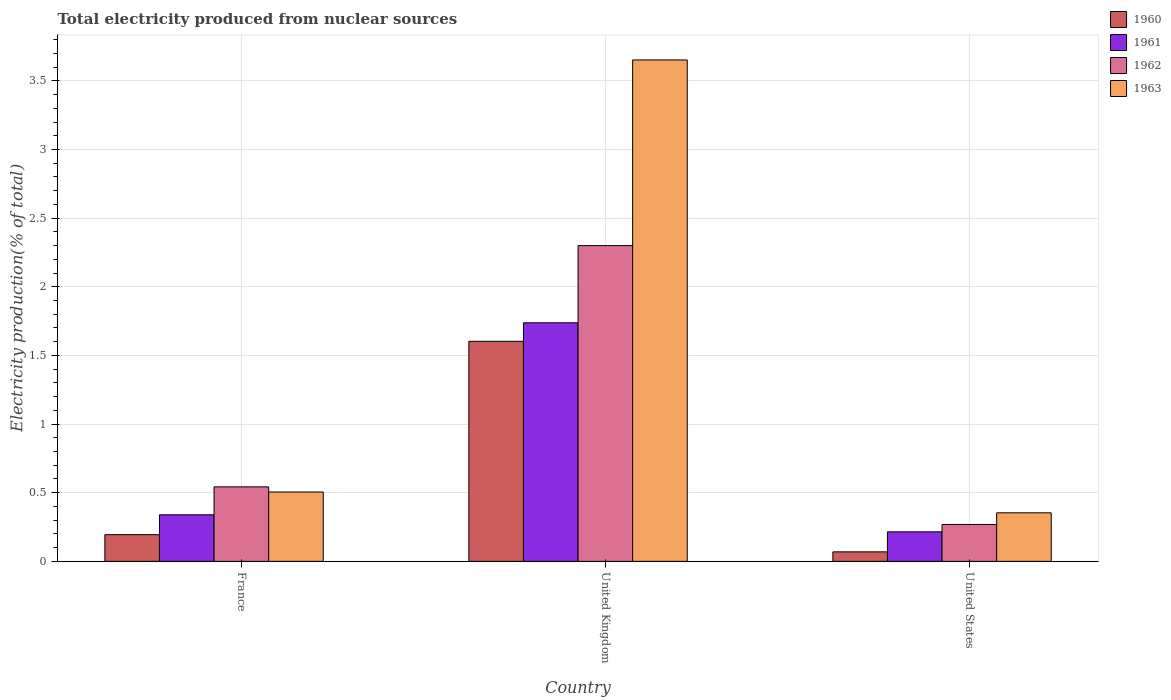How many different coloured bars are there?
Your answer should be very brief. 4. How many groups of bars are there?
Give a very brief answer. 3. Are the number of bars on each tick of the X-axis equal?
Keep it short and to the point. Yes. How many bars are there on the 3rd tick from the left?
Offer a very short reply. 4. What is the label of the 1st group of bars from the left?
Make the answer very short. France. In how many cases, is the number of bars for a given country not equal to the number of legend labels?
Your answer should be very brief. 0. What is the total electricity produced in 1961 in United Kingdom?
Give a very brief answer. 1.74. Across all countries, what is the maximum total electricity produced in 1962?
Your response must be concise. 2.3. Across all countries, what is the minimum total electricity produced in 1960?
Your answer should be compact. 0.07. What is the total total electricity produced in 1960 in the graph?
Your response must be concise. 1.87. What is the difference between the total electricity produced in 1960 in France and that in United Kingdom?
Make the answer very short. -1.41. What is the difference between the total electricity produced in 1962 in United Kingdom and the total electricity produced in 1960 in France?
Your answer should be very brief. 2.11. What is the average total electricity produced in 1963 per country?
Your response must be concise. 1.5. What is the difference between the total electricity produced of/in 1961 and total electricity produced of/in 1960 in France?
Your response must be concise. 0.14. In how many countries, is the total electricity produced in 1960 greater than 1.7 %?
Keep it short and to the point. 0. What is the ratio of the total electricity produced in 1962 in United Kingdom to that in United States?
Ensure brevity in your answer.  8.56. Is the total electricity produced in 1961 in France less than that in United States?
Your answer should be compact. No. Is the difference between the total electricity produced in 1961 in France and United States greater than the difference between the total electricity produced in 1960 in France and United States?
Make the answer very short. No. What is the difference between the highest and the second highest total electricity produced in 1963?
Your answer should be compact. -3.15. What is the difference between the highest and the lowest total electricity produced in 1963?
Give a very brief answer. 3.3. In how many countries, is the total electricity produced in 1960 greater than the average total electricity produced in 1960 taken over all countries?
Your answer should be compact. 1. Is the sum of the total electricity produced in 1963 in United Kingdom and United States greater than the maximum total electricity produced in 1961 across all countries?
Ensure brevity in your answer.  Yes. Is it the case that in every country, the sum of the total electricity produced in 1961 and total electricity produced in 1963 is greater than the sum of total electricity produced in 1962 and total electricity produced in 1960?
Provide a short and direct response. Yes. Is it the case that in every country, the sum of the total electricity produced in 1961 and total electricity produced in 1963 is greater than the total electricity produced in 1960?
Provide a succinct answer. Yes. How many bars are there?
Offer a terse response. 12. Are all the bars in the graph horizontal?
Make the answer very short. No. How many countries are there in the graph?
Give a very brief answer. 3. Does the graph contain any zero values?
Offer a very short reply. No. Where does the legend appear in the graph?
Your answer should be very brief. Top right. What is the title of the graph?
Provide a short and direct response. Total electricity produced from nuclear sources. Does "2010" appear as one of the legend labels in the graph?
Your answer should be compact. No. What is the label or title of the Y-axis?
Make the answer very short. Electricity production(% of total). What is the Electricity production(% of total) of 1960 in France?
Make the answer very short. 0.19. What is the Electricity production(% of total) of 1961 in France?
Your answer should be compact. 0.34. What is the Electricity production(% of total) in 1962 in France?
Your answer should be very brief. 0.54. What is the Electricity production(% of total) of 1963 in France?
Provide a succinct answer. 0.51. What is the Electricity production(% of total) in 1960 in United Kingdom?
Keep it short and to the point. 1.6. What is the Electricity production(% of total) of 1961 in United Kingdom?
Your response must be concise. 1.74. What is the Electricity production(% of total) in 1962 in United Kingdom?
Your answer should be compact. 2.3. What is the Electricity production(% of total) in 1963 in United Kingdom?
Make the answer very short. 3.65. What is the Electricity production(% of total) of 1960 in United States?
Keep it short and to the point. 0.07. What is the Electricity production(% of total) of 1961 in United States?
Make the answer very short. 0.22. What is the Electricity production(% of total) in 1962 in United States?
Provide a short and direct response. 0.27. What is the Electricity production(% of total) in 1963 in United States?
Offer a very short reply. 0.35. Across all countries, what is the maximum Electricity production(% of total) in 1960?
Make the answer very short. 1.6. Across all countries, what is the maximum Electricity production(% of total) of 1961?
Keep it short and to the point. 1.74. Across all countries, what is the maximum Electricity production(% of total) in 1962?
Offer a very short reply. 2.3. Across all countries, what is the maximum Electricity production(% of total) in 1963?
Your answer should be very brief. 3.65. Across all countries, what is the minimum Electricity production(% of total) in 1960?
Your response must be concise. 0.07. Across all countries, what is the minimum Electricity production(% of total) of 1961?
Your response must be concise. 0.22. Across all countries, what is the minimum Electricity production(% of total) in 1962?
Your answer should be compact. 0.27. Across all countries, what is the minimum Electricity production(% of total) of 1963?
Keep it short and to the point. 0.35. What is the total Electricity production(% of total) in 1960 in the graph?
Offer a terse response. 1.87. What is the total Electricity production(% of total) of 1961 in the graph?
Provide a short and direct response. 2.29. What is the total Electricity production(% of total) of 1962 in the graph?
Ensure brevity in your answer.  3.11. What is the total Electricity production(% of total) in 1963 in the graph?
Ensure brevity in your answer.  4.51. What is the difference between the Electricity production(% of total) of 1960 in France and that in United Kingdom?
Make the answer very short. -1.41. What is the difference between the Electricity production(% of total) in 1961 in France and that in United Kingdom?
Make the answer very short. -1.4. What is the difference between the Electricity production(% of total) in 1962 in France and that in United Kingdom?
Offer a terse response. -1.76. What is the difference between the Electricity production(% of total) in 1963 in France and that in United Kingdom?
Offer a terse response. -3.15. What is the difference between the Electricity production(% of total) of 1960 in France and that in United States?
Ensure brevity in your answer.  0.13. What is the difference between the Electricity production(% of total) in 1961 in France and that in United States?
Make the answer very short. 0.12. What is the difference between the Electricity production(% of total) in 1962 in France and that in United States?
Provide a succinct answer. 0.27. What is the difference between the Electricity production(% of total) of 1963 in France and that in United States?
Offer a terse response. 0.15. What is the difference between the Electricity production(% of total) in 1960 in United Kingdom and that in United States?
Your response must be concise. 1.53. What is the difference between the Electricity production(% of total) in 1961 in United Kingdom and that in United States?
Give a very brief answer. 1.52. What is the difference between the Electricity production(% of total) in 1962 in United Kingdom and that in United States?
Provide a succinct answer. 2.03. What is the difference between the Electricity production(% of total) in 1963 in United Kingdom and that in United States?
Give a very brief answer. 3.3. What is the difference between the Electricity production(% of total) in 1960 in France and the Electricity production(% of total) in 1961 in United Kingdom?
Keep it short and to the point. -1.54. What is the difference between the Electricity production(% of total) in 1960 in France and the Electricity production(% of total) in 1962 in United Kingdom?
Keep it short and to the point. -2.11. What is the difference between the Electricity production(% of total) of 1960 in France and the Electricity production(% of total) of 1963 in United Kingdom?
Provide a succinct answer. -3.46. What is the difference between the Electricity production(% of total) in 1961 in France and the Electricity production(% of total) in 1962 in United Kingdom?
Your answer should be compact. -1.96. What is the difference between the Electricity production(% of total) of 1961 in France and the Electricity production(% of total) of 1963 in United Kingdom?
Your response must be concise. -3.31. What is the difference between the Electricity production(% of total) in 1962 in France and the Electricity production(% of total) in 1963 in United Kingdom?
Your response must be concise. -3.11. What is the difference between the Electricity production(% of total) of 1960 in France and the Electricity production(% of total) of 1961 in United States?
Make the answer very short. -0.02. What is the difference between the Electricity production(% of total) in 1960 in France and the Electricity production(% of total) in 1962 in United States?
Give a very brief answer. -0.07. What is the difference between the Electricity production(% of total) of 1960 in France and the Electricity production(% of total) of 1963 in United States?
Give a very brief answer. -0.16. What is the difference between the Electricity production(% of total) of 1961 in France and the Electricity production(% of total) of 1962 in United States?
Make the answer very short. 0.07. What is the difference between the Electricity production(% of total) in 1961 in France and the Electricity production(% of total) in 1963 in United States?
Give a very brief answer. -0.01. What is the difference between the Electricity production(% of total) of 1962 in France and the Electricity production(% of total) of 1963 in United States?
Give a very brief answer. 0.19. What is the difference between the Electricity production(% of total) in 1960 in United Kingdom and the Electricity production(% of total) in 1961 in United States?
Offer a very short reply. 1.39. What is the difference between the Electricity production(% of total) of 1960 in United Kingdom and the Electricity production(% of total) of 1962 in United States?
Provide a succinct answer. 1.33. What is the difference between the Electricity production(% of total) of 1960 in United Kingdom and the Electricity production(% of total) of 1963 in United States?
Your response must be concise. 1.25. What is the difference between the Electricity production(% of total) of 1961 in United Kingdom and the Electricity production(% of total) of 1962 in United States?
Offer a very short reply. 1.47. What is the difference between the Electricity production(% of total) of 1961 in United Kingdom and the Electricity production(% of total) of 1963 in United States?
Ensure brevity in your answer.  1.38. What is the difference between the Electricity production(% of total) of 1962 in United Kingdom and the Electricity production(% of total) of 1963 in United States?
Provide a short and direct response. 1.95. What is the average Electricity production(% of total) of 1960 per country?
Make the answer very short. 0.62. What is the average Electricity production(% of total) of 1961 per country?
Keep it short and to the point. 0.76. What is the average Electricity production(% of total) in 1962 per country?
Your answer should be compact. 1.04. What is the average Electricity production(% of total) of 1963 per country?
Your answer should be compact. 1.5. What is the difference between the Electricity production(% of total) in 1960 and Electricity production(% of total) in 1961 in France?
Your answer should be compact. -0.14. What is the difference between the Electricity production(% of total) in 1960 and Electricity production(% of total) in 1962 in France?
Your response must be concise. -0.35. What is the difference between the Electricity production(% of total) of 1960 and Electricity production(% of total) of 1963 in France?
Offer a terse response. -0.31. What is the difference between the Electricity production(% of total) in 1961 and Electricity production(% of total) in 1962 in France?
Your answer should be very brief. -0.2. What is the difference between the Electricity production(% of total) of 1961 and Electricity production(% of total) of 1963 in France?
Offer a terse response. -0.17. What is the difference between the Electricity production(% of total) in 1962 and Electricity production(% of total) in 1963 in France?
Your answer should be compact. 0.04. What is the difference between the Electricity production(% of total) in 1960 and Electricity production(% of total) in 1961 in United Kingdom?
Provide a succinct answer. -0.13. What is the difference between the Electricity production(% of total) of 1960 and Electricity production(% of total) of 1962 in United Kingdom?
Provide a succinct answer. -0.7. What is the difference between the Electricity production(% of total) in 1960 and Electricity production(% of total) in 1963 in United Kingdom?
Ensure brevity in your answer.  -2.05. What is the difference between the Electricity production(% of total) in 1961 and Electricity production(% of total) in 1962 in United Kingdom?
Make the answer very short. -0.56. What is the difference between the Electricity production(% of total) of 1961 and Electricity production(% of total) of 1963 in United Kingdom?
Your answer should be very brief. -1.91. What is the difference between the Electricity production(% of total) of 1962 and Electricity production(% of total) of 1963 in United Kingdom?
Offer a very short reply. -1.35. What is the difference between the Electricity production(% of total) in 1960 and Electricity production(% of total) in 1961 in United States?
Ensure brevity in your answer.  -0.15. What is the difference between the Electricity production(% of total) in 1960 and Electricity production(% of total) in 1962 in United States?
Give a very brief answer. -0.2. What is the difference between the Electricity production(% of total) in 1960 and Electricity production(% of total) in 1963 in United States?
Provide a short and direct response. -0.28. What is the difference between the Electricity production(% of total) of 1961 and Electricity production(% of total) of 1962 in United States?
Your answer should be very brief. -0.05. What is the difference between the Electricity production(% of total) of 1961 and Electricity production(% of total) of 1963 in United States?
Your answer should be very brief. -0.14. What is the difference between the Electricity production(% of total) in 1962 and Electricity production(% of total) in 1963 in United States?
Your answer should be compact. -0.09. What is the ratio of the Electricity production(% of total) in 1960 in France to that in United Kingdom?
Provide a short and direct response. 0.12. What is the ratio of the Electricity production(% of total) in 1961 in France to that in United Kingdom?
Give a very brief answer. 0.2. What is the ratio of the Electricity production(% of total) of 1962 in France to that in United Kingdom?
Ensure brevity in your answer.  0.24. What is the ratio of the Electricity production(% of total) in 1963 in France to that in United Kingdom?
Provide a short and direct response. 0.14. What is the ratio of the Electricity production(% of total) of 1960 in France to that in United States?
Provide a short and direct response. 2.81. What is the ratio of the Electricity production(% of total) of 1961 in France to that in United States?
Provide a short and direct response. 1.58. What is the ratio of the Electricity production(% of total) in 1962 in France to that in United States?
Give a very brief answer. 2.02. What is the ratio of the Electricity production(% of total) in 1963 in France to that in United States?
Offer a very short reply. 1.43. What is the ratio of the Electricity production(% of total) of 1960 in United Kingdom to that in United States?
Your answer should be very brief. 23.14. What is the ratio of the Electricity production(% of total) of 1961 in United Kingdom to that in United States?
Your answer should be very brief. 8.08. What is the ratio of the Electricity production(% of total) of 1962 in United Kingdom to that in United States?
Keep it short and to the point. 8.56. What is the ratio of the Electricity production(% of total) in 1963 in United Kingdom to that in United States?
Make the answer very short. 10.32. What is the difference between the highest and the second highest Electricity production(% of total) in 1960?
Keep it short and to the point. 1.41. What is the difference between the highest and the second highest Electricity production(% of total) of 1961?
Keep it short and to the point. 1.4. What is the difference between the highest and the second highest Electricity production(% of total) of 1962?
Keep it short and to the point. 1.76. What is the difference between the highest and the second highest Electricity production(% of total) of 1963?
Your answer should be very brief. 3.15. What is the difference between the highest and the lowest Electricity production(% of total) in 1960?
Your answer should be compact. 1.53. What is the difference between the highest and the lowest Electricity production(% of total) of 1961?
Offer a very short reply. 1.52. What is the difference between the highest and the lowest Electricity production(% of total) in 1962?
Your answer should be very brief. 2.03. What is the difference between the highest and the lowest Electricity production(% of total) in 1963?
Provide a succinct answer. 3.3. 